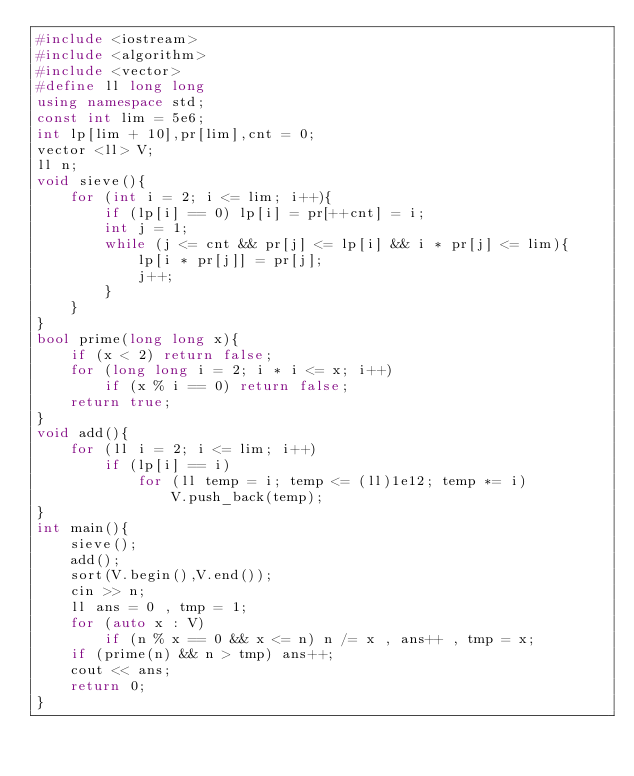Convert code to text. <code><loc_0><loc_0><loc_500><loc_500><_C++_>#include <iostream>
#include <algorithm>
#include <vector>
#define ll long long
using namespace std;
const int lim = 5e6;
int lp[lim + 10],pr[lim],cnt = 0;
vector <ll> V;
ll n;
void sieve(){
    for (int i = 2; i <= lim; i++){
        if (lp[i] == 0) lp[i] = pr[++cnt] = i;
        int j = 1;
        while (j <= cnt && pr[j] <= lp[i] && i * pr[j] <= lim){
            lp[i * pr[j]] = pr[j];
            j++;
        }
    }
}
bool prime(long long x){
    if (x < 2) return false;
    for (long long i = 2; i * i <= x; i++)
        if (x % i == 0) return false;
    return true;
}
void add(){
    for (ll i = 2; i <= lim; i++)
        if (lp[i] == i)
            for (ll temp = i; temp <= (ll)1e12; temp *= i)
                V.push_back(temp);
}
int main(){
    sieve();
    add();
    sort(V.begin(),V.end());
    cin >> n;
    ll ans = 0 , tmp = 1;
    for (auto x : V)
        if (n % x == 0 && x <= n) n /= x , ans++ , tmp = x;
    if (prime(n) && n > tmp) ans++;
    cout << ans;
    return 0;
}</code> 